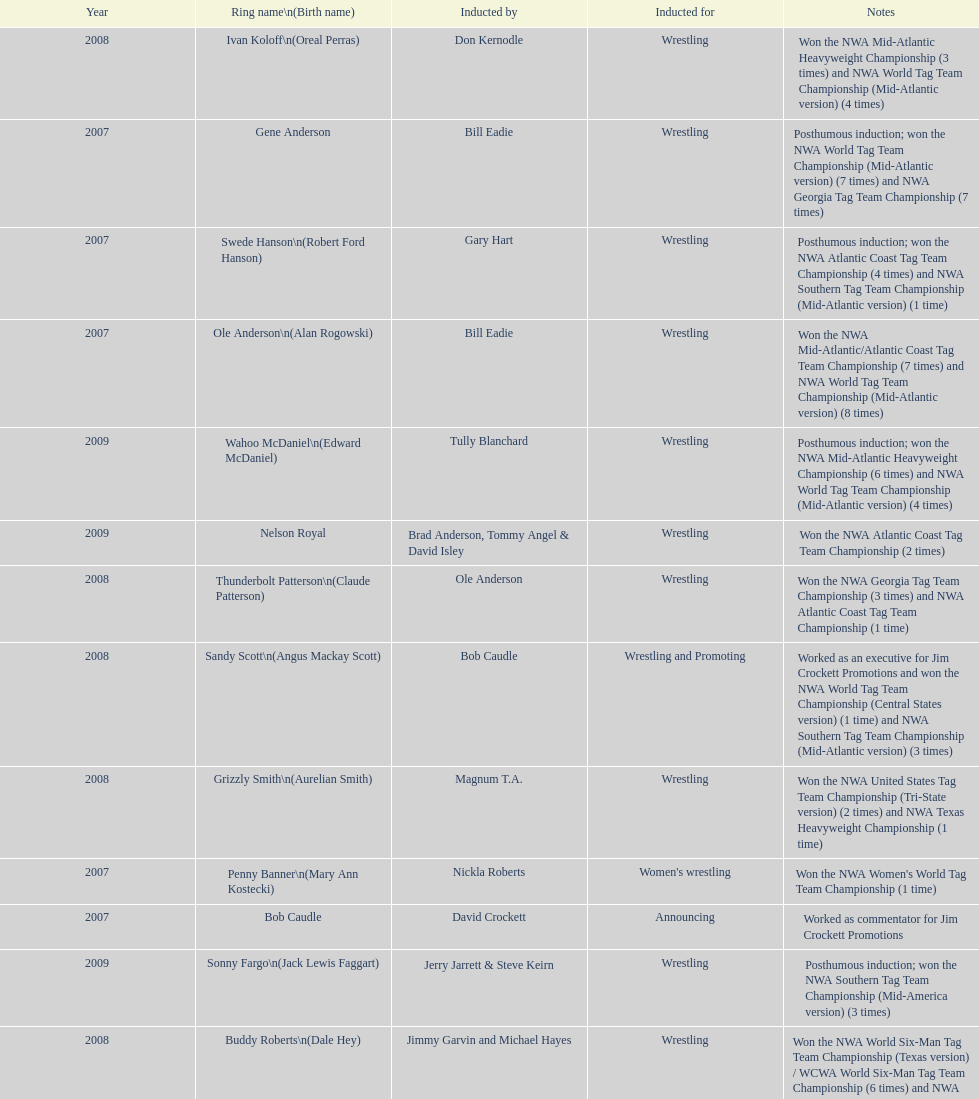Who's real name is dale hey, grizzly smith or buddy roberts? Buddy Roberts. 